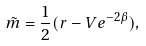<formula> <loc_0><loc_0><loc_500><loc_500>\tilde { m } = \frac { 1 } { 2 } ( r - V e ^ { - 2 \beta } ) ,</formula> 